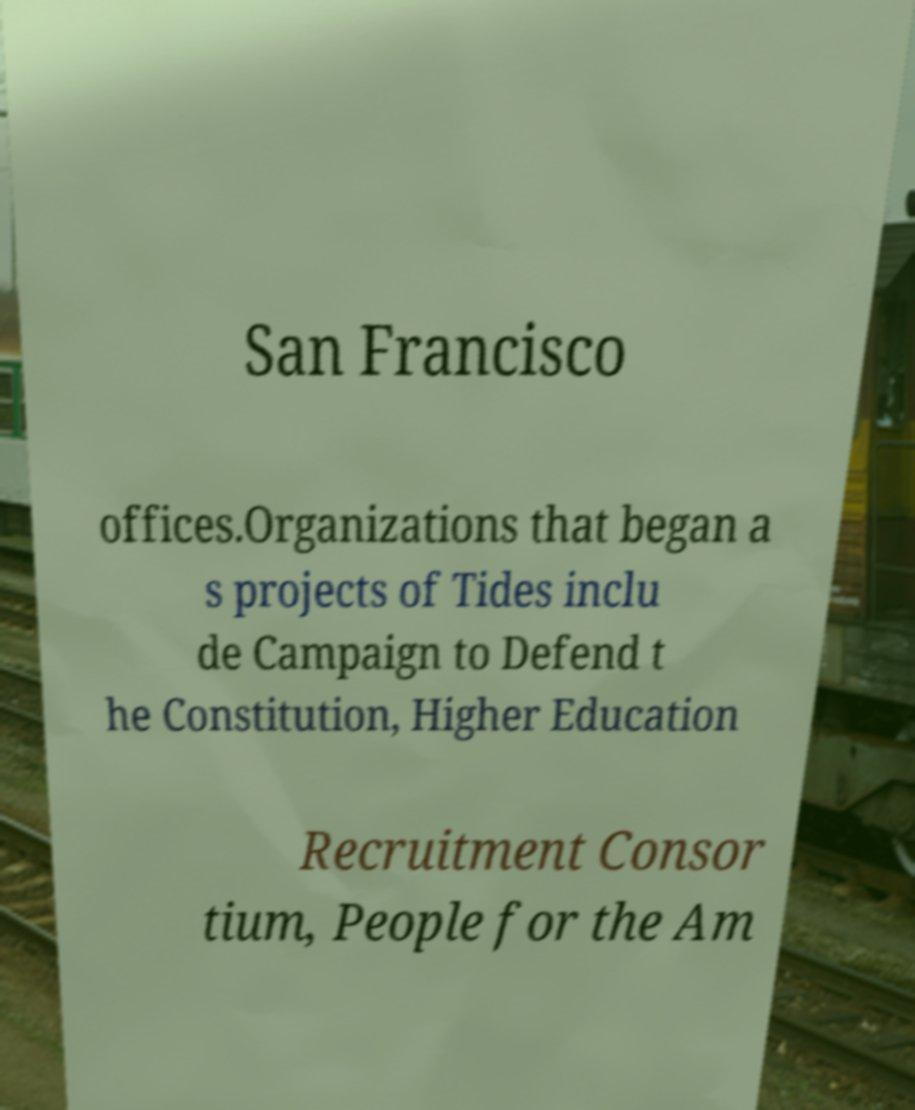I need the written content from this picture converted into text. Can you do that? San Francisco offices.Organizations that began a s projects of Tides inclu de Campaign to Defend t he Constitution, Higher Education Recruitment Consor tium, People for the Am 